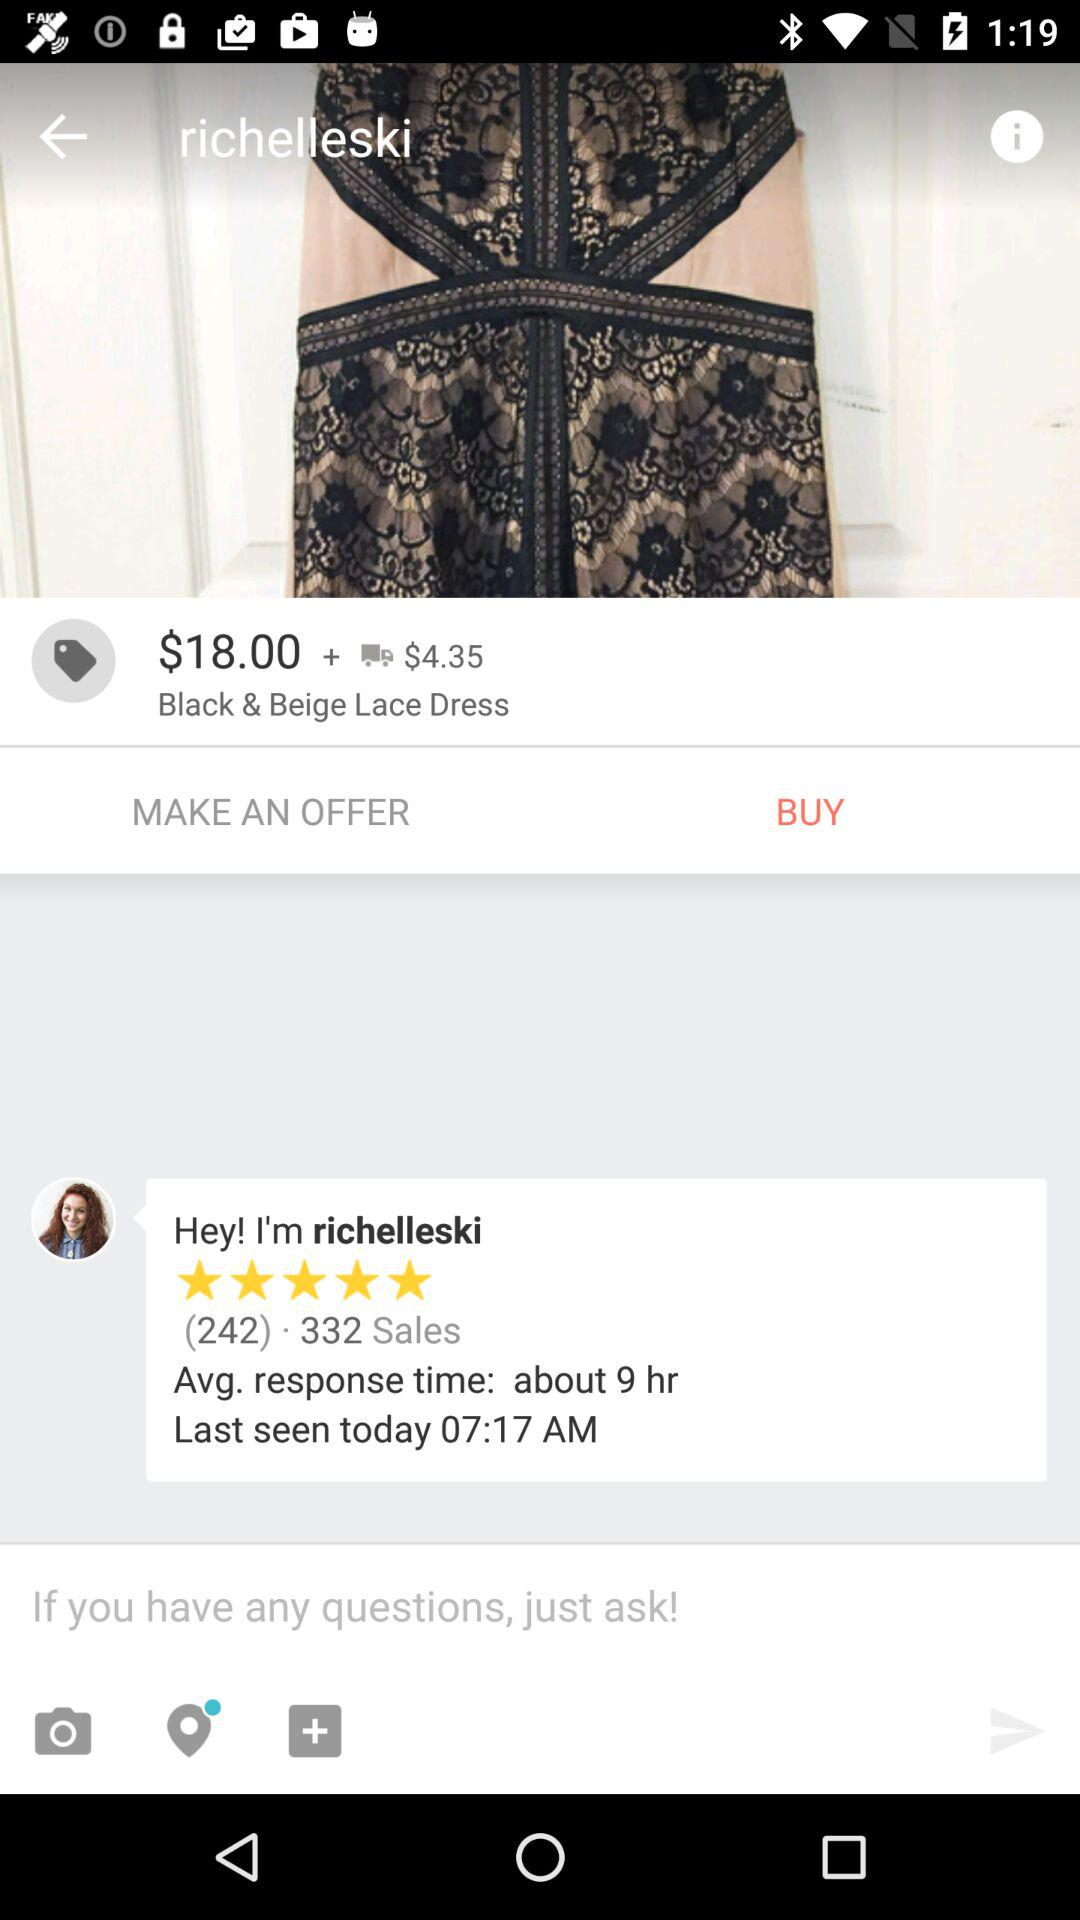What are the shipping charges for the "Black & Beige Lace Dress"? The shipping charges for the "Black & Beige Lace Dress" are $4.35. 